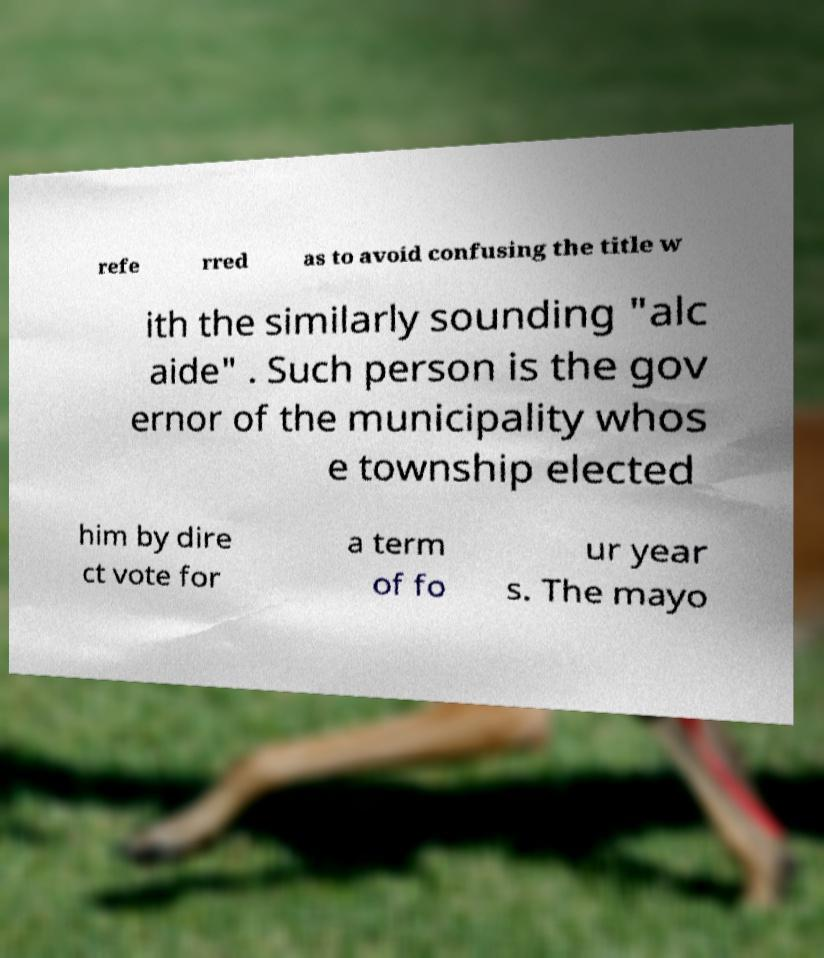There's text embedded in this image that I need extracted. Can you transcribe it verbatim? refe rred as to avoid confusing the title w ith the similarly sounding "alc aide" . Such person is the gov ernor of the municipality whos e township elected him by dire ct vote for a term of fo ur year s. The mayo 